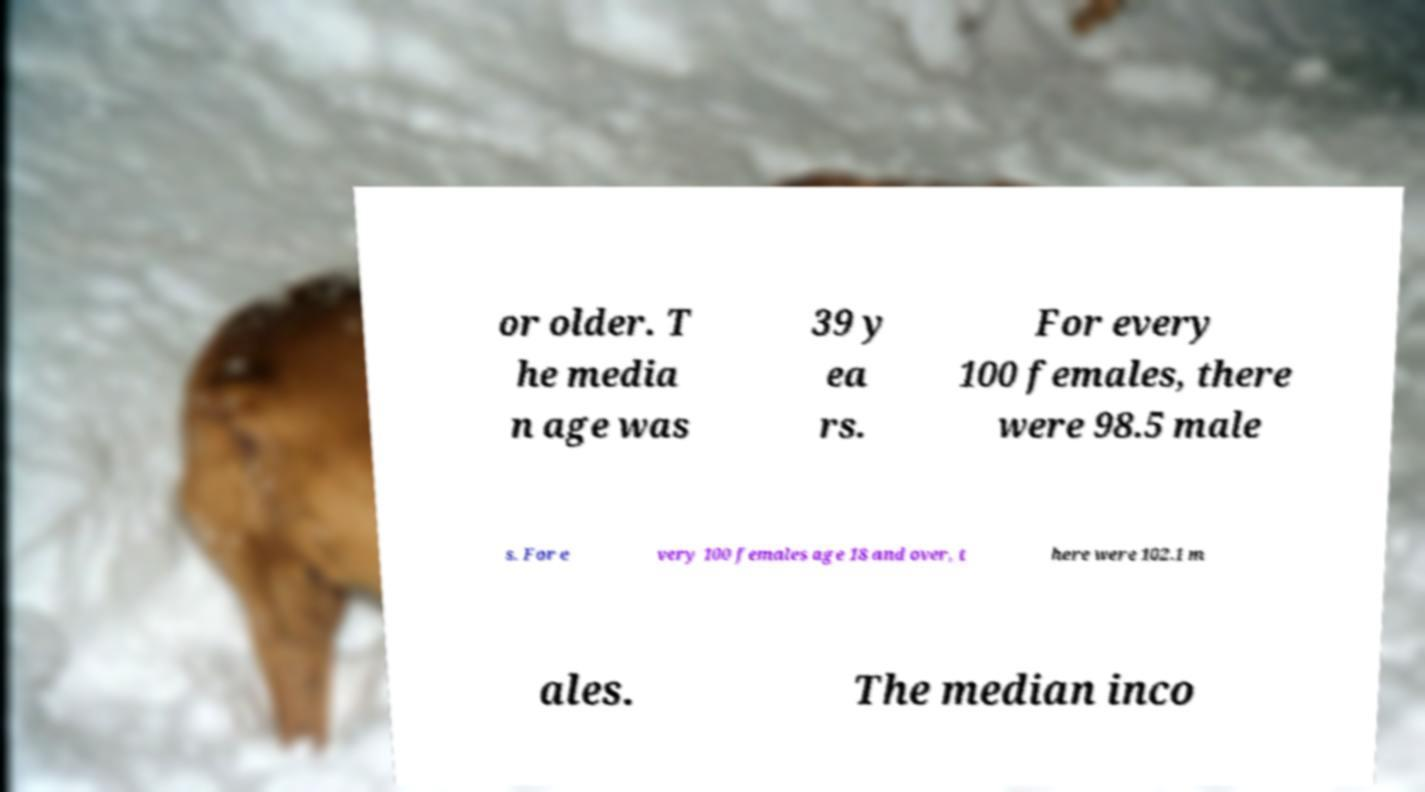Please identify and transcribe the text found in this image. or older. T he media n age was 39 y ea rs. For every 100 females, there were 98.5 male s. For e very 100 females age 18 and over, t here were 102.1 m ales. The median inco 